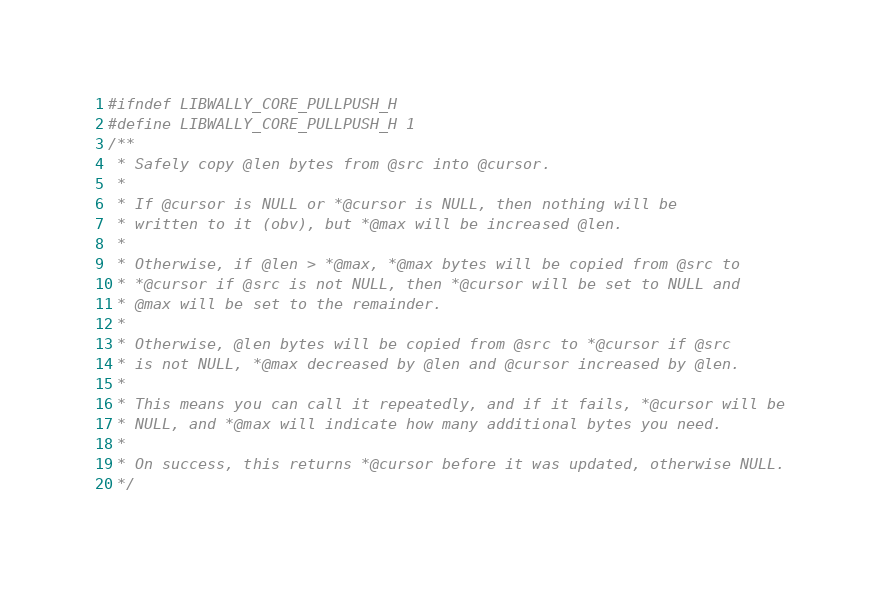Convert code to text. <code><loc_0><loc_0><loc_500><loc_500><_C_>#ifndef LIBWALLY_CORE_PULLPUSH_H
#define LIBWALLY_CORE_PULLPUSH_H 1
/**
 * Safely copy @len bytes from @src into @cursor.
 *
 * If @cursor is NULL or *@cursor is NULL, then nothing will be
 * written to it (obv), but *@max will be increased @len.
 *
 * Otherwise, if @len > *@max, *@max bytes will be copied from @src to
 * *@cursor if @src is not NULL, then *@cursor will be set to NULL and
 * @max will be set to the remainder.
 *
 * Otherwise, @len bytes will be copied from @src to *@cursor if @src
 * is not NULL, *@max decreased by @len and @cursor increased by @len.
 *
 * This means you can call it repeatedly, and if it fails, *@cursor will be
 * NULL, and *@max will indicate how many additional bytes you need.
 *
 * On success, this returns *@cursor before it was updated, otherwise NULL.
 */</code> 